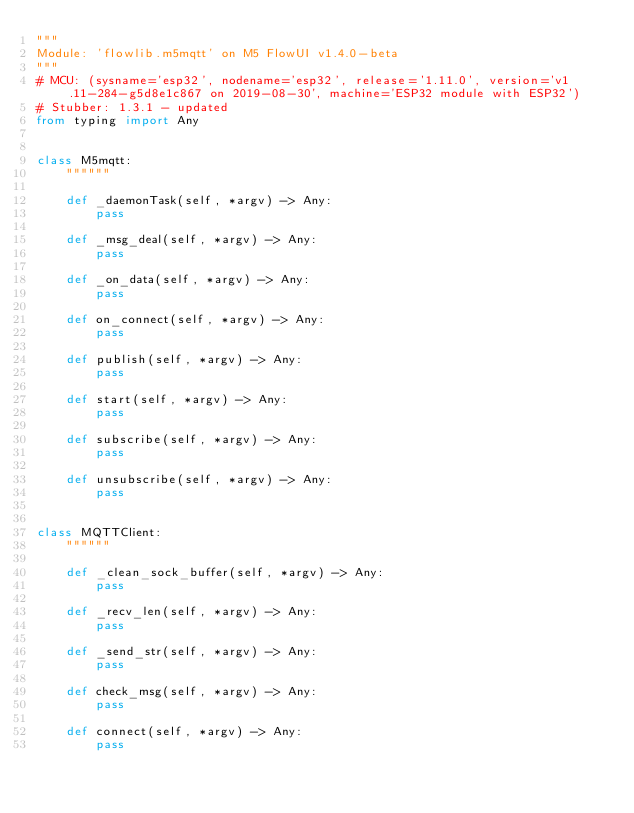<code> <loc_0><loc_0><loc_500><loc_500><_Python_>"""
Module: 'flowlib.m5mqtt' on M5 FlowUI v1.4.0-beta
"""
# MCU: (sysname='esp32', nodename='esp32', release='1.11.0', version='v1.11-284-g5d8e1c867 on 2019-08-30', machine='ESP32 module with ESP32')
# Stubber: 1.3.1 - updated
from typing import Any


class M5mqtt:
    """"""

    def _daemonTask(self, *argv) -> Any:
        pass

    def _msg_deal(self, *argv) -> Any:
        pass

    def _on_data(self, *argv) -> Any:
        pass

    def on_connect(self, *argv) -> Any:
        pass

    def publish(self, *argv) -> Any:
        pass

    def start(self, *argv) -> Any:
        pass

    def subscribe(self, *argv) -> Any:
        pass

    def unsubscribe(self, *argv) -> Any:
        pass


class MQTTClient:
    """"""

    def _clean_sock_buffer(self, *argv) -> Any:
        pass

    def _recv_len(self, *argv) -> Any:
        pass

    def _send_str(self, *argv) -> Any:
        pass

    def check_msg(self, *argv) -> Any:
        pass

    def connect(self, *argv) -> Any:
        pass
</code> 